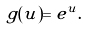<formula> <loc_0><loc_0><loc_500><loc_500>g ( u ) = e ^ { u } .</formula> 